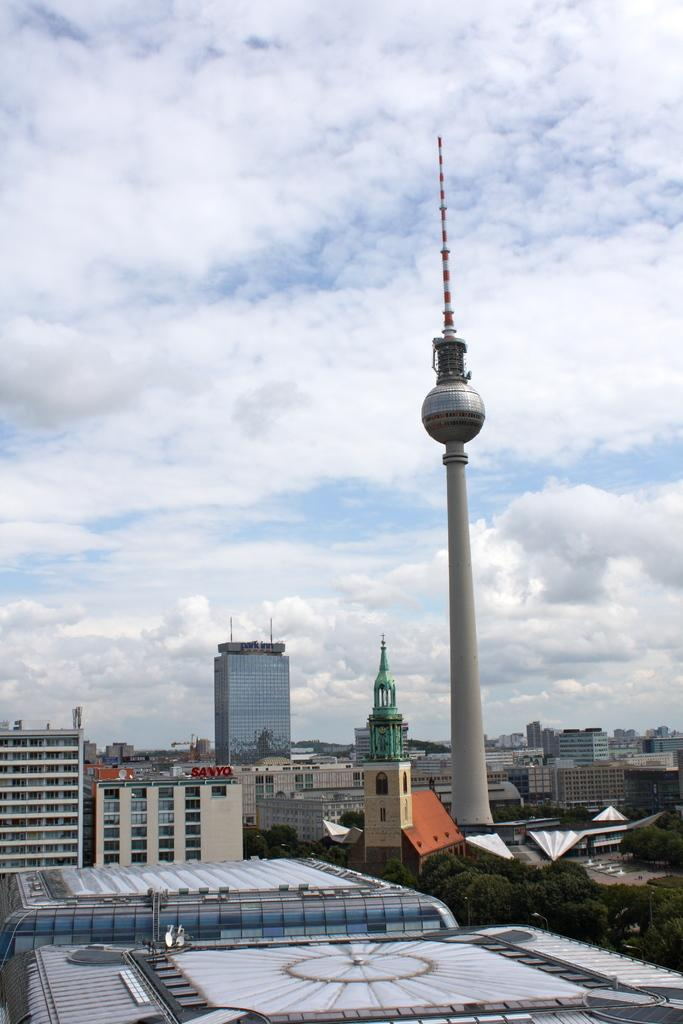What type of structures can be seen in the image? There are buildings in the image, including tower buildings. Can you describe any specific construction in the image? Yes, there is a pole construction in the image. What is visible in the background of the image? The sky is visible in the image. What can be observed in the sky? Clouds are present in the sky. What topic is being discussed in the image? There is no discussion taking place in the image; it is a still image of buildings, tower buildings, a pole construction, and the sky with clouds. 